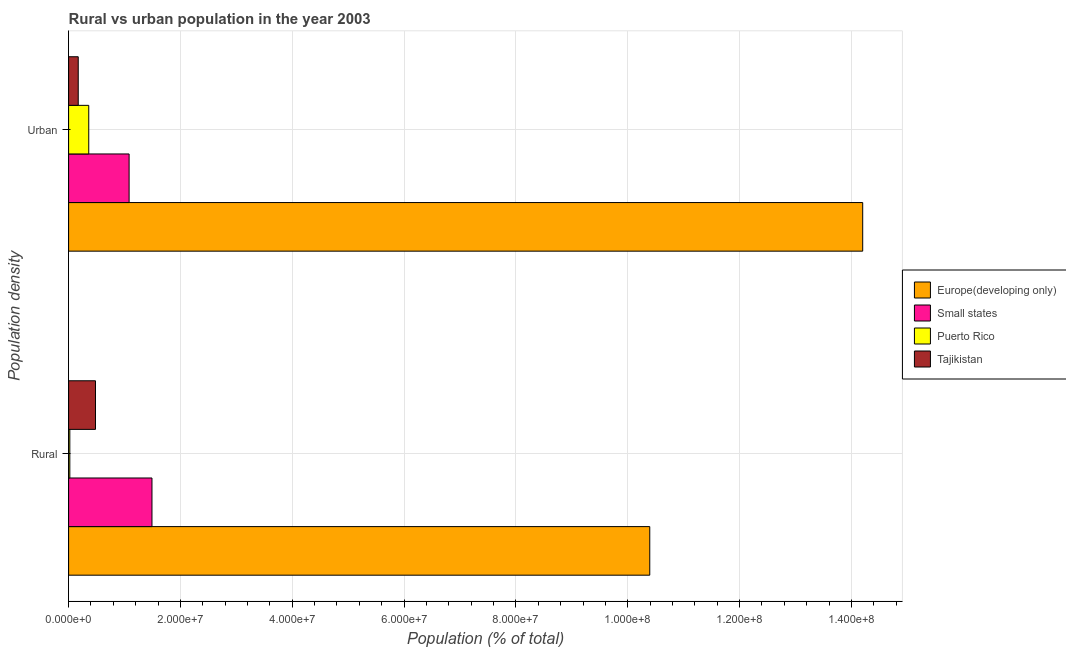How many groups of bars are there?
Ensure brevity in your answer.  2. What is the label of the 1st group of bars from the top?
Your answer should be very brief. Urban. What is the rural population density in Small states?
Offer a terse response. 1.49e+07. Across all countries, what is the maximum urban population density?
Provide a succinct answer. 1.42e+08. Across all countries, what is the minimum urban population density?
Your answer should be compact. 1.72e+06. In which country was the rural population density maximum?
Ensure brevity in your answer.  Europe(developing only). In which country was the rural population density minimum?
Offer a very short reply. Puerto Rico. What is the total rural population density in the graph?
Your answer should be very brief. 1.24e+08. What is the difference between the rural population density in Puerto Rico and that in Tajikistan?
Your answer should be compact. -4.59e+06. What is the difference between the rural population density in Small states and the urban population density in Tajikistan?
Provide a short and direct response. 1.32e+07. What is the average rural population density per country?
Provide a succinct answer. 3.10e+07. What is the difference between the rural population density and urban population density in Tajikistan?
Offer a terse response. 3.08e+06. In how many countries, is the urban population density greater than 100000000 %?
Offer a terse response. 1. What is the ratio of the urban population density in Small states to that in Europe(developing only)?
Give a very brief answer. 0.08. Is the rural population density in Tajikistan less than that in Europe(developing only)?
Offer a very short reply. Yes. In how many countries, is the urban population density greater than the average urban population density taken over all countries?
Your answer should be compact. 1. What does the 2nd bar from the top in Urban represents?
Offer a very short reply. Puerto Rico. What does the 2nd bar from the bottom in Rural represents?
Provide a succinct answer. Small states. Are the values on the major ticks of X-axis written in scientific E-notation?
Make the answer very short. Yes. Where does the legend appear in the graph?
Offer a terse response. Center right. What is the title of the graph?
Keep it short and to the point. Rural vs urban population in the year 2003. What is the label or title of the X-axis?
Provide a short and direct response. Population (% of total). What is the label or title of the Y-axis?
Give a very brief answer. Population density. What is the Population (% of total) in Europe(developing only) in Rural?
Your answer should be very brief. 1.04e+08. What is the Population (% of total) of Small states in Rural?
Make the answer very short. 1.49e+07. What is the Population (% of total) in Puerto Rico in Rural?
Ensure brevity in your answer.  2.21e+05. What is the Population (% of total) in Tajikistan in Rural?
Offer a terse response. 4.81e+06. What is the Population (% of total) in Europe(developing only) in Urban?
Ensure brevity in your answer.  1.42e+08. What is the Population (% of total) of Small states in Urban?
Provide a short and direct response. 1.08e+07. What is the Population (% of total) of Puerto Rico in Urban?
Make the answer very short. 3.61e+06. What is the Population (% of total) of Tajikistan in Urban?
Your response must be concise. 1.72e+06. Across all Population density, what is the maximum Population (% of total) in Europe(developing only)?
Make the answer very short. 1.42e+08. Across all Population density, what is the maximum Population (% of total) in Small states?
Your answer should be very brief. 1.49e+07. Across all Population density, what is the maximum Population (% of total) in Puerto Rico?
Give a very brief answer. 3.61e+06. Across all Population density, what is the maximum Population (% of total) in Tajikistan?
Offer a very short reply. 4.81e+06. Across all Population density, what is the minimum Population (% of total) in Europe(developing only)?
Give a very brief answer. 1.04e+08. Across all Population density, what is the minimum Population (% of total) in Small states?
Offer a terse response. 1.08e+07. Across all Population density, what is the minimum Population (% of total) of Puerto Rico?
Keep it short and to the point. 2.21e+05. Across all Population density, what is the minimum Population (% of total) in Tajikistan?
Keep it short and to the point. 1.72e+06. What is the total Population (% of total) in Europe(developing only) in the graph?
Your answer should be very brief. 2.46e+08. What is the total Population (% of total) of Small states in the graph?
Your response must be concise. 2.57e+07. What is the total Population (% of total) in Puerto Rico in the graph?
Your response must be concise. 3.83e+06. What is the total Population (% of total) of Tajikistan in the graph?
Your response must be concise. 6.53e+06. What is the difference between the Population (% of total) in Europe(developing only) in Rural and that in Urban?
Offer a terse response. -3.81e+07. What is the difference between the Population (% of total) of Small states in Rural and that in Urban?
Make the answer very short. 4.09e+06. What is the difference between the Population (% of total) of Puerto Rico in Rural and that in Urban?
Your response must be concise. -3.38e+06. What is the difference between the Population (% of total) of Tajikistan in Rural and that in Urban?
Your answer should be compact. 3.08e+06. What is the difference between the Population (% of total) of Europe(developing only) in Rural and the Population (% of total) of Small states in Urban?
Ensure brevity in your answer.  9.31e+07. What is the difference between the Population (% of total) of Europe(developing only) in Rural and the Population (% of total) of Puerto Rico in Urban?
Ensure brevity in your answer.  1.00e+08. What is the difference between the Population (% of total) in Europe(developing only) in Rural and the Population (% of total) in Tajikistan in Urban?
Offer a very short reply. 1.02e+08. What is the difference between the Population (% of total) of Small states in Rural and the Population (% of total) of Puerto Rico in Urban?
Make the answer very short. 1.13e+07. What is the difference between the Population (% of total) in Small states in Rural and the Population (% of total) in Tajikistan in Urban?
Give a very brief answer. 1.32e+07. What is the difference between the Population (% of total) in Puerto Rico in Rural and the Population (% of total) in Tajikistan in Urban?
Offer a very short reply. -1.50e+06. What is the average Population (% of total) of Europe(developing only) per Population density?
Offer a terse response. 1.23e+08. What is the average Population (% of total) in Small states per Population density?
Provide a short and direct response. 1.29e+07. What is the average Population (% of total) in Puerto Rico per Population density?
Ensure brevity in your answer.  1.91e+06. What is the average Population (% of total) of Tajikistan per Population density?
Your response must be concise. 3.27e+06. What is the difference between the Population (% of total) of Europe(developing only) and Population (% of total) of Small states in Rural?
Make the answer very short. 8.90e+07. What is the difference between the Population (% of total) in Europe(developing only) and Population (% of total) in Puerto Rico in Rural?
Provide a succinct answer. 1.04e+08. What is the difference between the Population (% of total) of Europe(developing only) and Population (% of total) of Tajikistan in Rural?
Your answer should be very brief. 9.91e+07. What is the difference between the Population (% of total) of Small states and Population (% of total) of Puerto Rico in Rural?
Provide a short and direct response. 1.47e+07. What is the difference between the Population (% of total) in Small states and Population (% of total) in Tajikistan in Rural?
Make the answer very short. 1.01e+07. What is the difference between the Population (% of total) in Puerto Rico and Population (% of total) in Tajikistan in Rural?
Provide a short and direct response. -4.59e+06. What is the difference between the Population (% of total) in Europe(developing only) and Population (% of total) in Small states in Urban?
Your answer should be very brief. 1.31e+08. What is the difference between the Population (% of total) in Europe(developing only) and Population (% of total) in Puerto Rico in Urban?
Your response must be concise. 1.38e+08. What is the difference between the Population (% of total) in Europe(developing only) and Population (% of total) in Tajikistan in Urban?
Give a very brief answer. 1.40e+08. What is the difference between the Population (% of total) of Small states and Population (% of total) of Puerto Rico in Urban?
Your answer should be compact. 7.22e+06. What is the difference between the Population (% of total) in Small states and Population (% of total) in Tajikistan in Urban?
Offer a terse response. 9.10e+06. What is the difference between the Population (% of total) of Puerto Rico and Population (% of total) of Tajikistan in Urban?
Your response must be concise. 1.88e+06. What is the ratio of the Population (% of total) of Europe(developing only) in Rural to that in Urban?
Ensure brevity in your answer.  0.73. What is the ratio of the Population (% of total) in Small states in Rural to that in Urban?
Your answer should be compact. 1.38. What is the ratio of the Population (% of total) of Puerto Rico in Rural to that in Urban?
Provide a short and direct response. 0.06. What is the ratio of the Population (% of total) of Tajikistan in Rural to that in Urban?
Your answer should be compact. 2.79. What is the difference between the highest and the second highest Population (% of total) in Europe(developing only)?
Offer a terse response. 3.81e+07. What is the difference between the highest and the second highest Population (% of total) of Small states?
Ensure brevity in your answer.  4.09e+06. What is the difference between the highest and the second highest Population (% of total) of Puerto Rico?
Offer a very short reply. 3.38e+06. What is the difference between the highest and the second highest Population (% of total) in Tajikistan?
Make the answer very short. 3.08e+06. What is the difference between the highest and the lowest Population (% of total) in Europe(developing only)?
Your answer should be very brief. 3.81e+07. What is the difference between the highest and the lowest Population (% of total) of Small states?
Your answer should be compact. 4.09e+06. What is the difference between the highest and the lowest Population (% of total) of Puerto Rico?
Offer a terse response. 3.38e+06. What is the difference between the highest and the lowest Population (% of total) in Tajikistan?
Provide a succinct answer. 3.08e+06. 